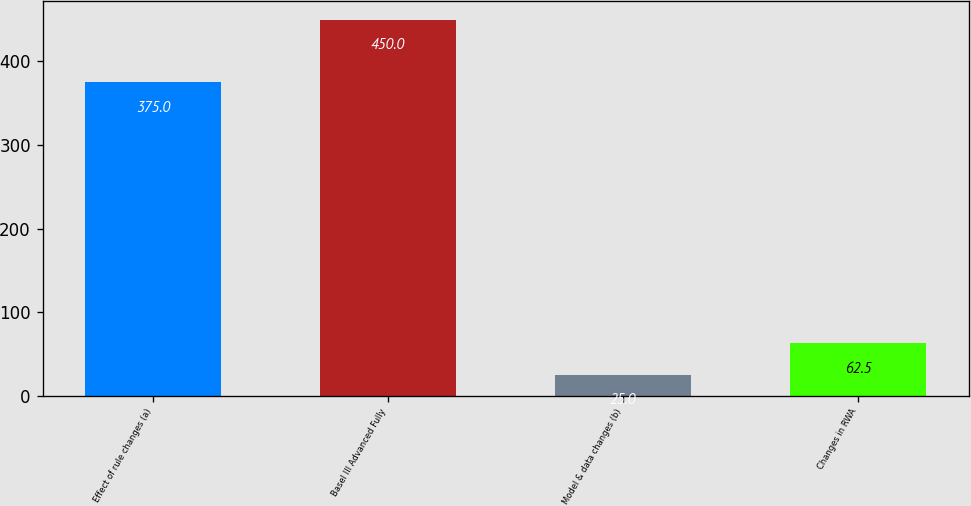Convert chart to OTSL. <chart><loc_0><loc_0><loc_500><loc_500><bar_chart><fcel>Effect of rule changes (a)<fcel>Basel III Advanced Fully<fcel>Model & data changes (b)<fcel>Changes in RWA<nl><fcel>375<fcel>450<fcel>25<fcel>62.5<nl></chart> 